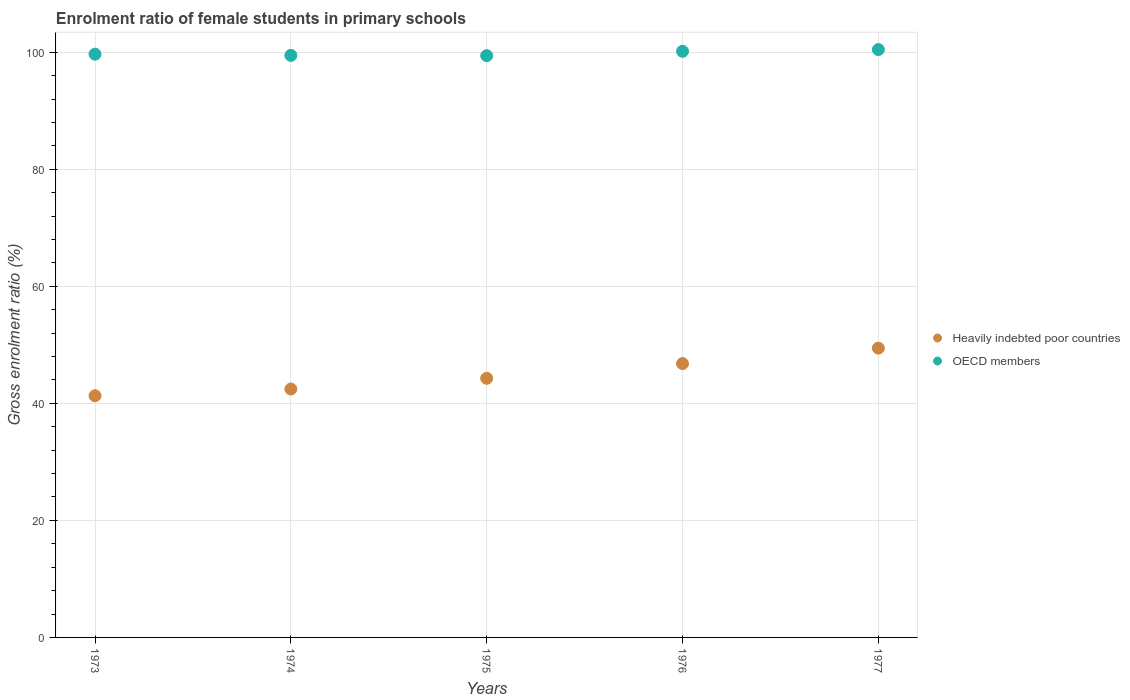How many different coloured dotlines are there?
Your response must be concise. 2. What is the enrolment ratio of female students in primary schools in OECD members in 1973?
Your response must be concise. 99.68. Across all years, what is the maximum enrolment ratio of female students in primary schools in OECD members?
Your response must be concise. 100.46. Across all years, what is the minimum enrolment ratio of female students in primary schools in Heavily indebted poor countries?
Your answer should be compact. 41.3. In which year was the enrolment ratio of female students in primary schools in OECD members minimum?
Give a very brief answer. 1975. What is the total enrolment ratio of female students in primary schools in OECD members in the graph?
Make the answer very short. 499.2. What is the difference between the enrolment ratio of female students in primary schools in OECD members in 1974 and that in 1976?
Give a very brief answer. -0.7. What is the difference between the enrolment ratio of female students in primary schools in Heavily indebted poor countries in 1973 and the enrolment ratio of female students in primary schools in OECD members in 1974?
Your response must be concise. -58.17. What is the average enrolment ratio of female students in primary schools in Heavily indebted poor countries per year?
Offer a very short reply. 44.86. In the year 1973, what is the difference between the enrolment ratio of female students in primary schools in OECD members and enrolment ratio of female students in primary schools in Heavily indebted poor countries?
Your response must be concise. 58.37. In how many years, is the enrolment ratio of female students in primary schools in Heavily indebted poor countries greater than 80 %?
Your answer should be very brief. 0. What is the ratio of the enrolment ratio of female students in primary schools in Heavily indebted poor countries in 1976 to that in 1977?
Your response must be concise. 0.95. Is the enrolment ratio of female students in primary schools in OECD members in 1973 less than that in 1974?
Offer a terse response. No. Is the difference between the enrolment ratio of female students in primary schools in OECD members in 1973 and 1975 greater than the difference between the enrolment ratio of female students in primary schools in Heavily indebted poor countries in 1973 and 1975?
Provide a short and direct response. Yes. What is the difference between the highest and the second highest enrolment ratio of female students in primary schools in Heavily indebted poor countries?
Provide a succinct answer. 2.64. What is the difference between the highest and the lowest enrolment ratio of female students in primary schools in OECD members?
Keep it short and to the point. 1.04. Is the enrolment ratio of female students in primary schools in Heavily indebted poor countries strictly greater than the enrolment ratio of female students in primary schools in OECD members over the years?
Provide a succinct answer. No. Is the enrolment ratio of female students in primary schools in OECD members strictly less than the enrolment ratio of female students in primary schools in Heavily indebted poor countries over the years?
Offer a terse response. No. How many dotlines are there?
Ensure brevity in your answer.  2. Are the values on the major ticks of Y-axis written in scientific E-notation?
Your answer should be compact. No. Does the graph contain any zero values?
Offer a very short reply. No. Does the graph contain grids?
Provide a succinct answer. Yes. What is the title of the graph?
Offer a terse response. Enrolment ratio of female students in primary schools. What is the label or title of the X-axis?
Your response must be concise. Years. What is the label or title of the Y-axis?
Your answer should be compact. Gross enrolment ratio (%). What is the Gross enrolment ratio (%) of Heavily indebted poor countries in 1973?
Your answer should be compact. 41.3. What is the Gross enrolment ratio (%) in OECD members in 1973?
Provide a short and direct response. 99.68. What is the Gross enrolment ratio (%) of Heavily indebted poor countries in 1974?
Keep it short and to the point. 42.45. What is the Gross enrolment ratio (%) in OECD members in 1974?
Provide a succinct answer. 99.47. What is the Gross enrolment ratio (%) of Heavily indebted poor countries in 1975?
Your response must be concise. 44.28. What is the Gross enrolment ratio (%) in OECD members in 1975?
Keep it short and to the point. 99.42. What is the Gross enrolment ratio (%) in Heavily indebted poor countries in 1976?
Ensure brevity in your answer.  46.8. What is the Gross enrolment ratio (%) in OECD members in 1976?
Offer a very short reply. 100.17. What is the Gross enrolment ratio (%) in Heavily indebted poor countries in 1977?
Make the answer very short. 49.44. What is the Gross enrolment ratio (%) in OECD members in 1977?
Your response must be concise. 100.46. Across all years, what is the maximum Gross enrolment ratio (%) of Heavily indebted poor countries?
Your answer should be compact. 49.44. Across all years, what is the maximum Gross enrolment ratio (%) of OECD members?
Provide a short and direct response. 100.46. Across all years, what is the minimum Gross enrolment ratio (%) of Heavily indebted poor countries?
Provide a succinct answer. 41.3. Across all years, what is the minimum Gross enrolment ratio (%) of OECD members?
Ensure brevity in your answer.  99.42. What is the total Gross enrolment ratio (%) of Heavily indebted poor countries in the graph?
Provide a short and direct response. 224.28. What is the total Gross enrolment ratio (%) of OECD members in the graph?
Provide a succinct answer. 499.2. What is the difference between the Gross enrolment ratio (%) of Heavily indebted poor countries in 1973 and that in 1974?
Ensure brevity in your answer.  -1.15. What is the difference between the Gross enrolment ratio (%) in OECD members in 1973 and that in 1974?
Give a very brief answer. 0.21. What is the difference between the Gross enrolment ratio (%) in Heavily indebted poor countries in 1973 and that in 1975?
Offer a terse response. -2.98. What is the difference between the Gross enrolment ratio (%) of OECD members in 1973 and that in 1975?
Give a very brief answer. 0.25. What is the difference between the Gross enrolment ratio (%) of Heavily indebted poor countries in 1973 and that in 1976?
Ensure brevity in your answer.  -5.5. What is the difference between the Gross enrolment ratio (%) in OECD members in 1973 and that in 1976?
Keep it short and to the point. -0.49. What is the difference between the Gross enrolment ratio (%) in Heavily indebted poor countries in 1973 and that in 1977?
Make the answer very short. -8.14. What is the difference between the Gross enrolment ratio (%) in OECD members in 1973 and that in 1977?
Ensure brevity in your answer.  -0.79. What is the difference between the Gross enrolment ratio (%) of Heavily indebted poor countries in 1974 and that in 1975?
Your response must be concise. -1.83. What is the difference between the Gross enrolment ratio (%) in OECD members in 1974 and that in 1975?
Your answer should be compact. 0.05. What is the difference between the Gross enrolment ratio (%) of Heavily indebted poor countries in 1974 and that in 1976?
Make the answer very short. -4.35. What is the difference between the Gross enrolment ratio (%) of Heavily indebted poor countries in 1974 and that in 1977?
Ensure brevity in your answer.  -6.99. What is the difference between the Gross enrolment ratio (%) in OECD members in 1974 and that in 1977?
Offer a very short reply. -1. What is the difference between the Gross enrolment ratio (%) in Heavily indebted poor countries in 1975 and that in 1976?
Make the answer very short. -2.52. What is the difference between the Gross enrolment ratio (%) of OECD members in 1975 and that in 1976?
Your response must be concise. -0.75. What is the difference between the Gross enrolment ratio (%) of Heavily indebted poor countries in 1975 and that in 1977?
Offer a very short reply. -5.16. What is the difference between the Gross enrolment ratio (%) in OECD members in 1975 and that in 1977?
Provide a short and direct response. -1.04. What is the difference between the Gross enrolment ratio (%) in Heavily indebted poor countries in 1976 and that in 1977?
Offer a terse response. -2.64. What is the difference between the Gross enrolment ratio (%) in OECD members in 1976 and that in 1977?
Offer a very short reply. -0.3. What is the difference between the Gross enrolment ratio (%) of Heavily indebted poor countries in 1973 and the Gross enrolment ratio (%) of OECD members in 1974?
Provide a succinct answer. -58.17. What is the difference between the Gross enrolment ratio (%) of Heavily indebted poor countries in 1973 and the Gross enrolment ratio (%) of OECD members in 1975?
Make the answer very short. -58.12. What is the difference between the Gross enrolment ratio (%) of Heavily indebted poor countries in 1973 and the Gross enrolment ratio (%) of OECD members in 1976?
Offer a very short reply. -58.87. What is the difference between the Gross enrolment ratio (%) of Heavily indebted poor countries in 1973 and the Gross enrolment ratio (%) of OECD members in 1977?
Your answer should be very brief. -59.16. What is the difference between the Gross enrolment ratio (%) in Heavily indebted poor countries in 1974 and the Gross enrolment ratio (%) in OECD members in 1975?
Your answer should be very brief. -56.97. What is the difference between the Gross enrolment ratio (%) of Heavily indebted poor countries in 1974 and the Gross enrolment ratio (%) of OECD members in 1976?
Give a very brief answer. -57.72. What is the difference between the Gross enrolment ratio (%) of Heavily indebted poor countries in 1974 and the Gross enrolment ratio (%) of OECD members in 1977?
Ensure brevity in your answer.  -58.01. What is the difference between the Gross enrolment ratio (%) of Heavily indebted poor countries in 1975 and the Gross enrolment ratio (%) of OECD members in 1976?
Offer a terse response. -55.88. What is the difference between the Gross enrolment ratio (%) in Heavily indebted poor countries in 1975 and the Gross enrolment ratio (%) in OECD members in 1977?
Offer a terse response. -56.18. What is the difference between the Gross enrolment ratio (%) of Heavily indebted poor countries in 1976 and the Gross enrolment ratio (%) of OECD members in 1977?
Keep it short and to the point. -53.66. What is the average Gross enrolment ratio (%) of Heavily indebted poor countries per year?
Give a very brief answer. 44.86. What is the average Gross enrolment ratio (%) in OECD members per year?
Make the answer very short. 99.84. In the year 1973, what is the difference between the Gross enrolment ratio (%) of Heavily indebted poor countries and Gross enrolment ratio (%) of OECD members?
Your answer should be compact. -58.37. In the year 1974, what is the difference between the Gross enrolment ratio (%) in Heavily indebted poor countries and Gross enrolment ratio (%) in OECD members?
Your answer should be compact. -57.02. In the year 1975, what is the difference between the Gross enrolment ratio (%) of Heavily indebted poor countries and Gross enrolment ratio (%) of OECD members?
Offer a terse response. -55.14. In the year 1976, what is the difference between the Gross enrolment ratio (%) in Heavily indebted poor countries and Gross enrolment ratio (%) in OECD members?
Provide a succinct answer. -53.37. In the year 1977, what is the difference between the Gross enrolment ratio (%) in Heavily indebted poor countries and Gross enrolment ratio (%) in OECD members?
Make the answer very short. -51.02. What is the ratio of the Gross enrolment ratio (%) in Heavily indebted poor countries in 1973 to that in 1975?
Provide a short and direct response. 0.93. What is the ratio of the Gross enrolment ratio (%) in OECD members in 1973 to that in 1975?
Your response must be concise. 1. What is the ratio of the Gross enrolment ratio (%) of Heavily indebted poor countries in 1973 to that in 1976?
Offer a terse response. 0.88. What is the ratio of the Gross enrolment ratio (%) in OECD members in 1973 to that in 1976?
Give a very brief answer. 1. What is the ratio of the Gross enrolment ratio (%) in Heavily indebted poor countries in 1973 to that in 1977?
Provide a short and direct response. 0.84. What is the ratio of the Gross enrolment ratio (%) of Heavily indebted poor countries in 1974 to that in 1975?
Provide a succinct answer. 0.96. What is the ratio of the Gross enrolment ratio (%) in OECD members in 1974 to that in 1975?
Provide a succinct answer. 1. What is the ratio of the Gross enrolment ratio (%) of Heavily indebted poor countries in 1974 to that in 1976?
Make the answer very short. 0.91. What is the ratio of the Gross enrolment ratio (%) in OECD members in 1974 to that in 1976?
Your response must be concise. 0.99. What is the ratio of the Gross enrolment ratio (%) in Heavily indebted poor countries in 1974 to that in 1977?
Provide a succinct answer. 0.86. What is the ratio of the Gross enrolment ratio (%) in Heavily indebted poor countries in 1975 to that in 1976?
Your answer should be very brief. 0.95. What is the ratio of the Gross enrolment ratio (%) of OECD members in 1975 to that in 1976?
Ensure brevity in your answer.  0.99. What is the ratio of the Gross enrolment ratio (%) in Heavily indebted poor countries in 1975 to that in 1977?
Provide a short and direct response. 0.9. What is the ratio of the Gross enrolment ratio (%) in Heavily indebted poor countries in 1976 to that in 1977?
Keep it short and to the point. 0.95. What is the difference between the highest and the second highest Gross enrolment ratio (%) in Heavily indebted poor countries?
Your answer should be compact. 2.64. What is the difference between the highest and the second highest Gross enrolment ratio (%) in OECD members?
Offer a terse response. 0.3. What is the difference between the highest and the lowest Gross enrolment ratio (%) of Heavily indebted poor countries?
Provide a short and direct response. 8.14. What is the difference between the highest and the lowest Gross enrolment ratio (%) in OECD members?
Make the answer very short. 1.04. 